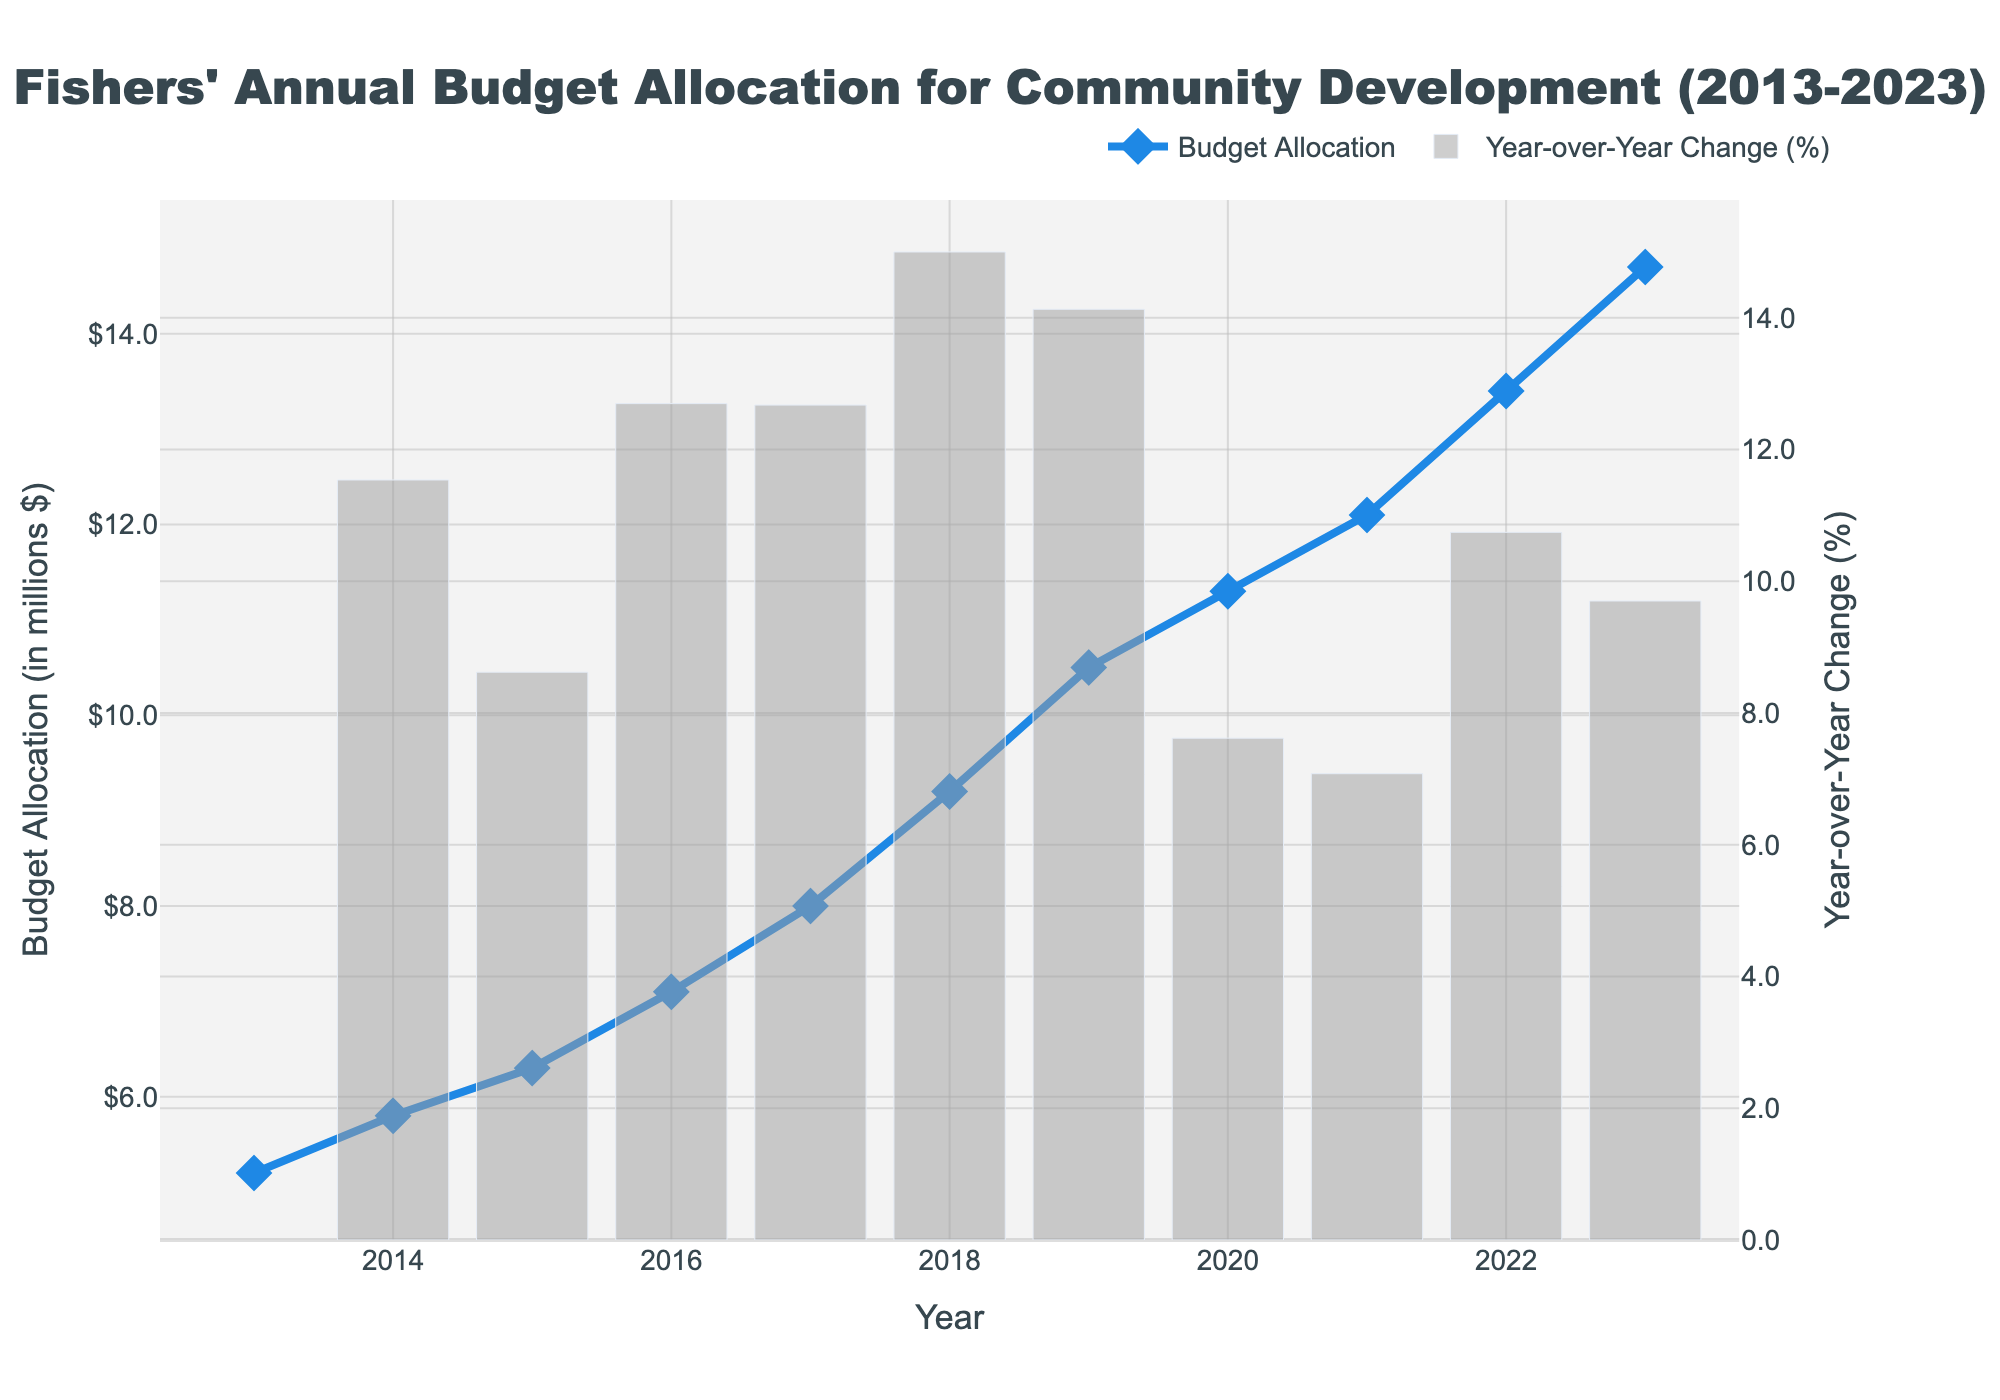What is the total budget allocation for community development over the last decade? Sum the budget allocations for each year: 5.2 + 5.8 + 6.3 + 7.1 + 8.0 + 9.2 + 10.5 + 11.3 + 12.1 + 13.4 + 14.7 = 93.6 million dollars.
Answer: 93.6 million dollars Which year saw the highest budget allocation for community development? Identify the highest value on the line graph and note the corresponding year, which is 2023 with 14.7 million dollars.
Answer: 2023 What was the budget allocation in 2018? Locate the value for the year 2018 on the x-axis and note the corresponding y-value, which is 9.2 million dollars.
Answer: 9.2 million dollars By how much did the budget allocation increase from 2017 to 2018? Subtract the 2017 budget allocation from the 2018 budget allocation: 9.2 - 8.0 = 1.2 million dollars.
Answer: 1.2 million dollars In which year did the budget allocation increase by the largest percentage compared to the previous year? Examine the bar plot for the year-over-year percentages and identify the tallest bar, which corresponds to 2014 with an increase of about 11.54%.
Answer: 2014 What was the average annual budget allocation for community development over the last decade? Sum the budget allocations for each year and divide by the number of years: (5.2 + 5.8 + 6.3 + 7.1 + 8.0 + 9.2 + 10.5 + 11.3 + 12.1 + 13.4 + 14.7) / 11 ≈ 8.5 million dollars.
Answer: 8.5 million dollars What is the amount by which the budget allocation increased from 2013 to 2023? Subtract the 2013 budget allocation from the 2023 budget allocation: 14.7 - 5.2 = 9.5 million dollars.
Answer: 9.5 million dollars How did the budget allocation change from 2019 to 2020? Note the budget allocation for both years and compute the difference: 11.3 - 10.5 = 0.8 million dollars increase.
Answer: 0.8 million dollars increase Which two consecutive years had the smallest year-over-year budget increase? Compare the height of the year-over-year change bars to find the smallest positive change, which occurred between 2018 and 2019 (around 14.13%).
Answer: 2018-2019 How did the budget allocation change from 2021 to 2022 in terms of percentage? Calculate the percentage change: (13.4 - 12.1) / 12.1 * 100 ≈ 10.74%.
Answer: 10.74% 